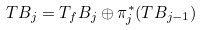Convert formula to latex. <formula><loc_0><loc_0><loc_500><loc_500>T B _ { j } = T _ { f } B _ { j } \oplus \pi _ { j } ^ { * } ( T B _ { j - 1 } )</formula> 